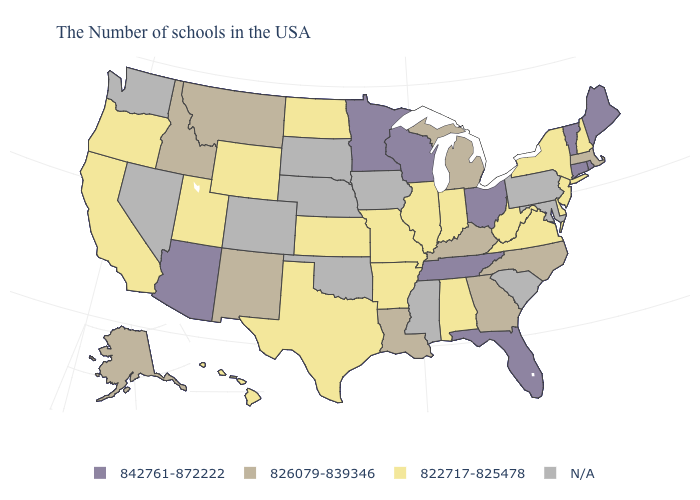Does the first symbol in the legend represent the smallest category?
Be succinct. No. What is the value of Massachusetts?
Short answer required. 826079-839346. Which states hav the highest value in the Northeast?
Write a very short answer. Maine, Rhode Island, Vermont, Connecticut. Name the states that have a value in the range 826079-839346?
Be succinct. Massachusetts, North Carolina, Georgia, Michigan, Kentucky, Louisiana, New Mexico, Montana, Idaho, Alaska. Does Arkansas have the highest value in the South?
Quick response, please. No. What is the highest value in states that border Minnesota?
Give a very brief answer. 842761-872222. Which states hav the highest value in the Northeast?
Short answer required. Maine, Rhode Island, Vermont, Connecticut. Is the legend a continuous bar?
Be succinct. No. Which states have the highest value in the USA?
Answer briefly. Maine, Rhode Island, Vermont, Connecticut, Ohio, Florida, Tennessee, Wisconsin, Minnesota, Arizona. Does Vermont have the highest value in the USA?
Quick response, please. Yes. What is the value of Idaho?
Keep it brief. 826079-839346. What is the value of Tennessee?
Be succinct. 842761-872222. Name the states that have a value in the range N/A?
Give a very brief answer. Maryland, Pennsylvania, South Carolina, Mississippi, Iowa, Nebraska, Oklahoma, South Dakota, Colorado, Nevada, Washington. Name the states that have a value in the range 842761-872222?
Answer briefly. Maine, Rhode Island, Vermont, Connecticut, Ohio, Florida, Tennessee, Wisconsin, Minnesota, Arizona. 